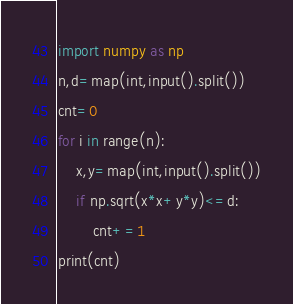Convert code to text. <code><loc_0><loc_0><loc_500><loc_500><_Python_>import numpy as np
n,d=map(int,input().split())
cnt=0
for i in range(n):
    x,y=map(int,input().split())
    if np.sqrt(x*x+y*y)<=d:
        cnt+=1
print(cnt)</code> 